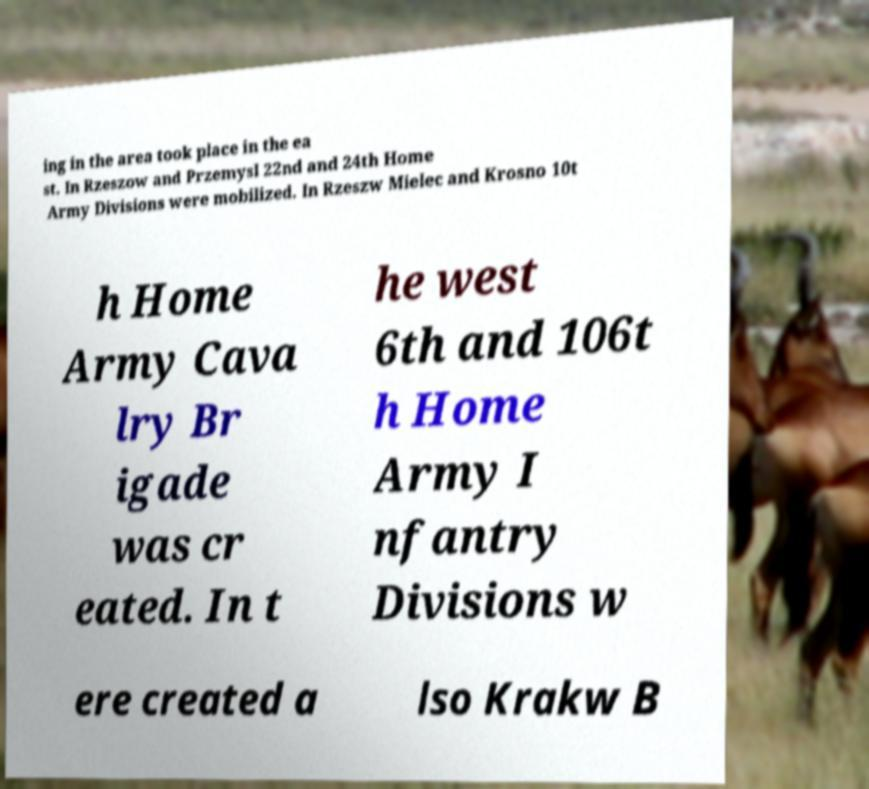Please read and relay the text visible in this image. What does it say? ing in the area took place in the ea st. In Rzeszow and Przemysl 22nd and 24th Home Army Divisions were mobilized. In Rzeszw Mielec and Krosno 10t h Home Army Cava lry Br igade was cr eated. In t he west 6th and 106t h Home Army I nfantry Divisions w ere created a lso Krakw B 